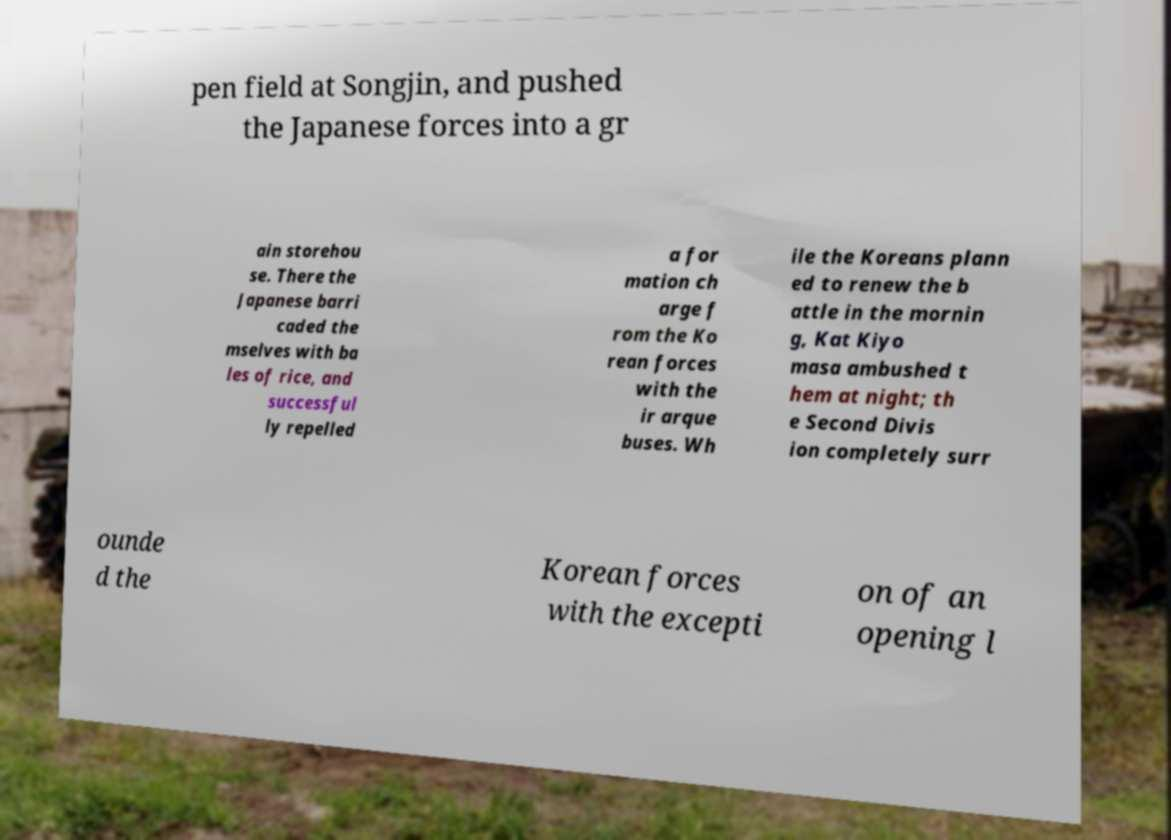Could you assist in decoding the text presented in this image and type it out clearly? pen field at Songjin, and pushed the Japanese forces into a gr ain storehou se. There the Japanese barri caded the mselves with ba les of rice, and successful ly repelled a for mation ch arge f rom the Ko rean forces with the ir arque buses. Wh ile the Koreans plann ed to renew the b attle in the mornin g, Kat Kiyo masa ambushed t hem at night; th e Second Divis ion completely surr ounde d the Korean forces with the excepti on of an opening l 